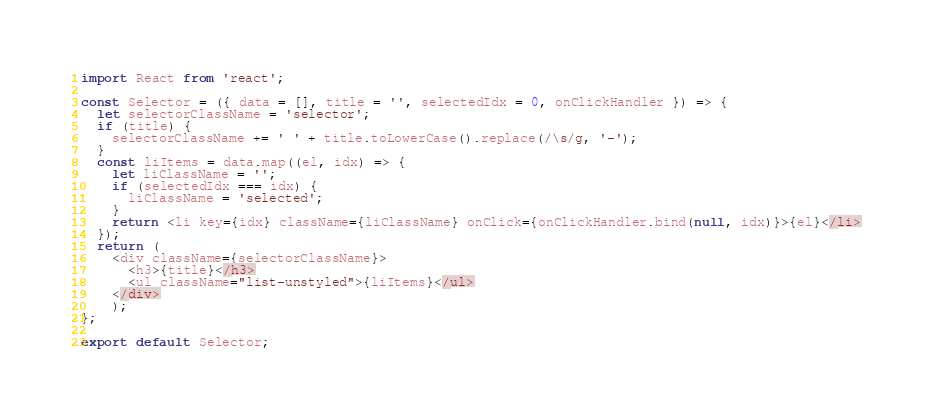Convert code to text. <code><loc_0><loc_0><loc_500><loc_500><_JavaScript_>import React from 'react';

const Selector = ({ data = [], title = '', selectedIdx = 0, onClickHandler }) => {
  let selectorClassName = 'selector';
  if (title) {
    selectorClassName += ' ' + title.toLowerCase().replace(/\s/g, '-');
  }
  const liItems = data.map((el, idx) => {
    let liClassName = '';
    if (selectedIdx === idx) {
      liClassName = 'selected';
    }
    return <li key={idx} className={liClassName} onClick={onClickHandler.bind(null, idx)}>{el}</li>
  });
  return (
    <div className={selectorClassName}>
      <h3>{title}</h3>
      <ul className="list-unstyled">{liItems}</ul>
    </div>
    );
};

export default Selector;
</code> 